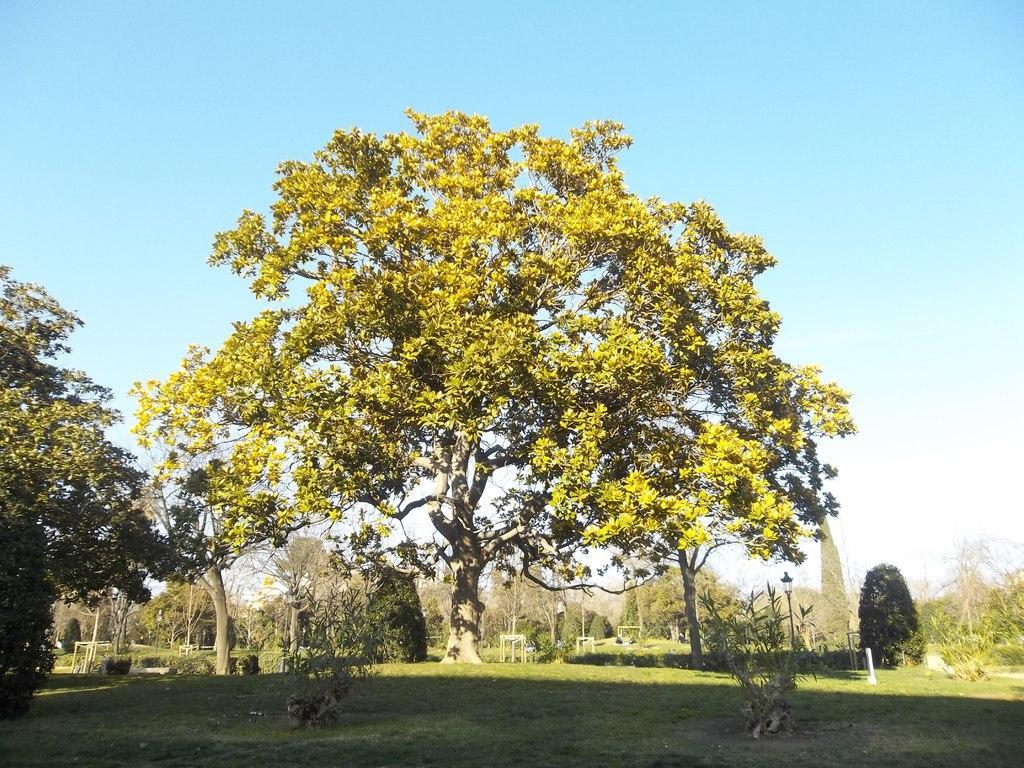Could you give a brief overview of what you see in this image? In this picture there is grassland at the bottom side of the image and there are trees in the center of the image and there is sky at the top side of the image. 